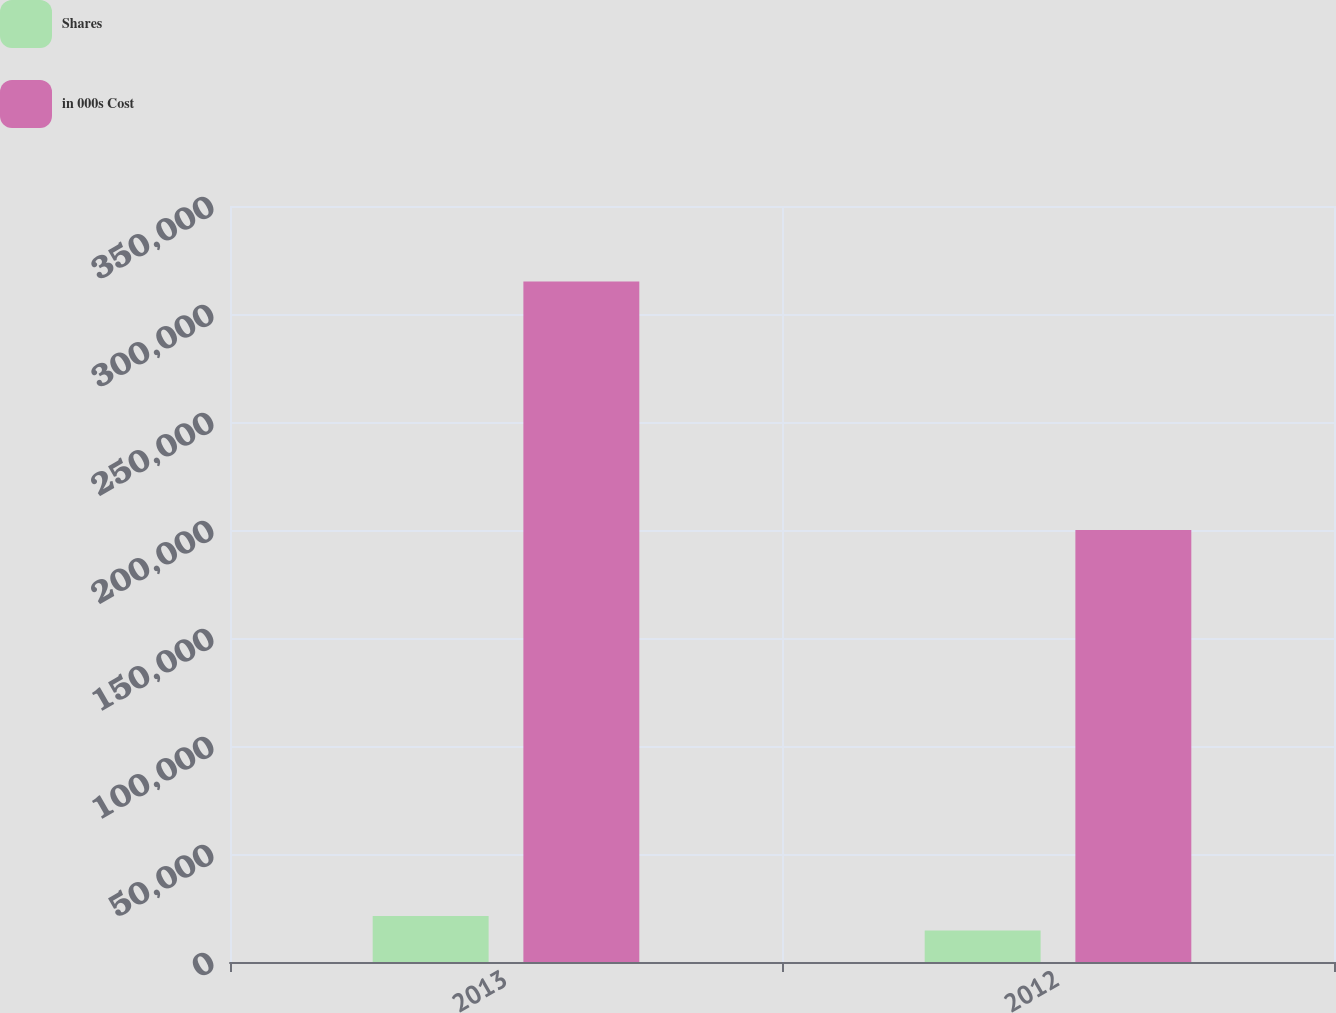<chart> <loc_0><loc_0><loc_500><loc_500><stacked_bar_chart><ecel><fcel>2013<fcel>2012<nl><fcel>Shares<fcel>21259<fcel>14554<nl><fcel>in 000s Cost<fcel>315000<fcel>199989<nl></chart> 